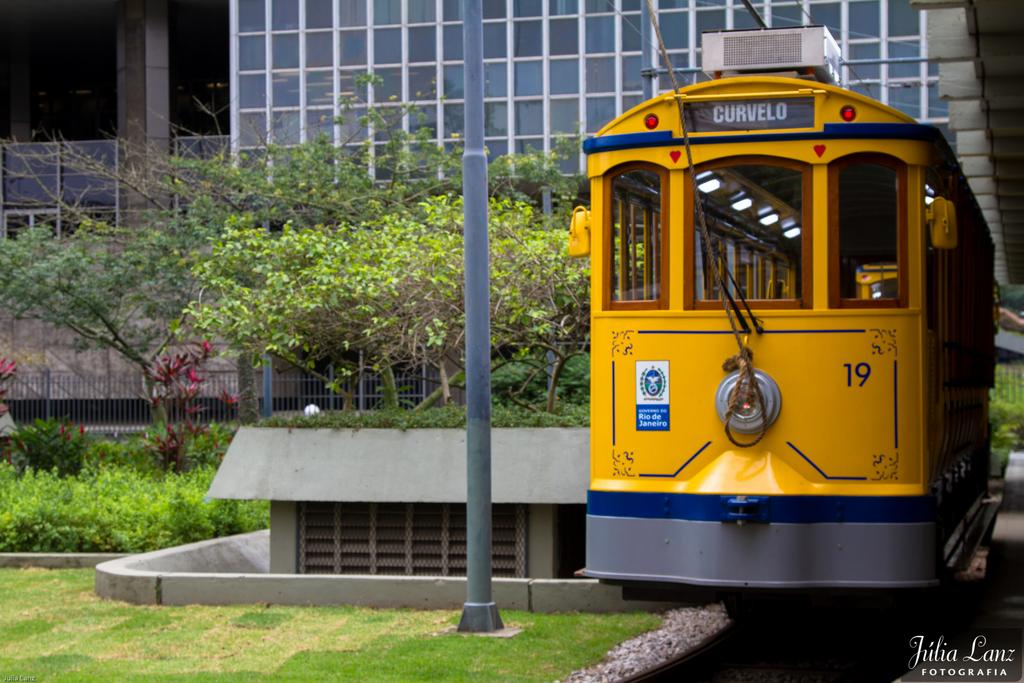What type of building is in the image? There is a glass building in the image. What other natural elements can be seen in the image? There are trees in the image. What is the pole used for in the image? The purpose of the pole is not specified, but it is visible in the image. What color is present in the image? The color yellow is present in the image. What architectural features can be seen in the image? There are pillars in the image. What other color object is in the image? There is a blue color object in the image. What type of poison is being used by the robin in the image? There is no robin or poison present in the image. What type of milk is being served in the image? There is no milk present in the image. 